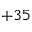<formula> <loc_0><loc_0><loc_500><loc_500>+ 3 5</formula> 